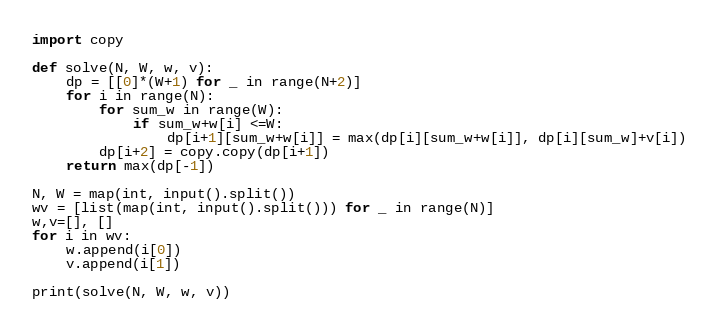<code> <loc_0><loc_0><loc_500><loc_500><_Python_>import copy

def solve(N, W, w, v):
    dp = [[0]*(W+1) for _ in range(N+2)]
    for i in range(N):
        for sum_w in range(W):
            if sum_w+w[i] <=W:
                dp[i+1][sum_w+w[i]] = max(dp[i][sum_w+w[i]], dp[i][sum_w]+v[i])
        dp[i+2] = copy.copy(dp[i+1])
    return max(dp[-1])

N, W = map(int, input().split())
wv = [list(map(int, input().split())) for _ in range(N)]
w,v=[], []
for i in wv:
    w.append(i[0])
    v.append(i[1])

print(solve(N, W, w, v))</code> 